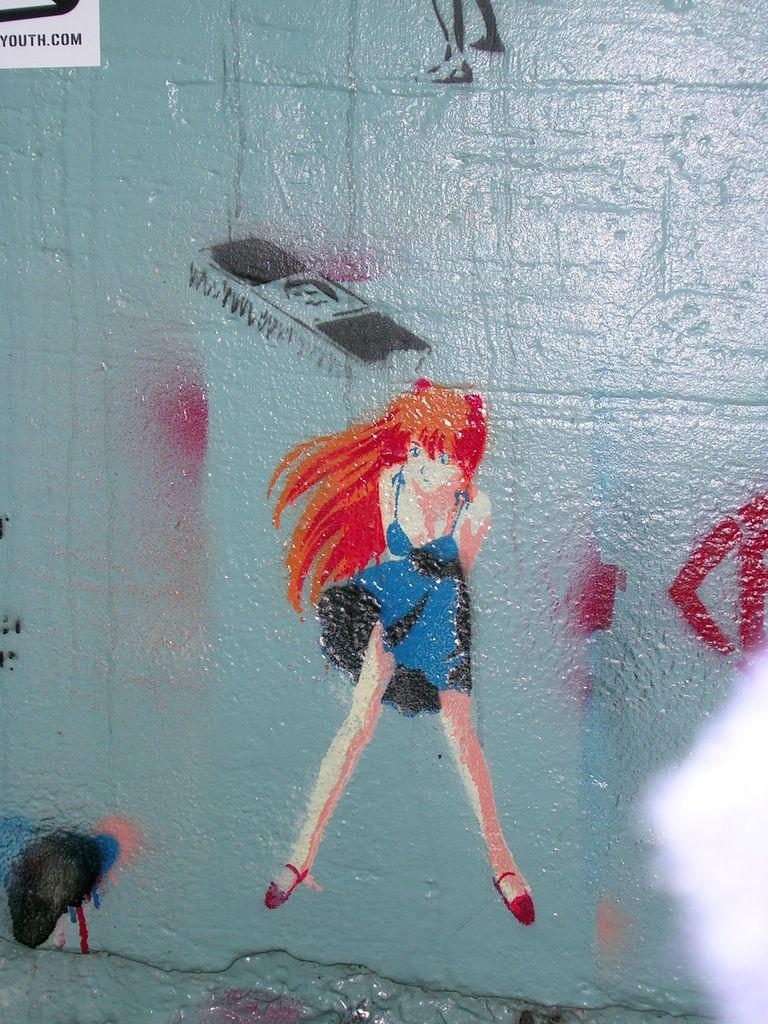What is on the wall in the image? There is a painting on the wall in the image. What is depicted in the painting? The painting contains a cartoon image of a woman. Is there any text visible in the image? Yes, there is text visible at the top left of the image. How does the painting contribute to pollution in the image? The painting does not contribute to pollution in the image; it is a static image on the wall. What type of waste is depicted in the painting? There is no waste depicted in the painting; it features a cartoon image of a woman. 